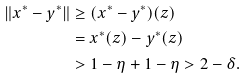Convert formula to latex. <formula><loc_0><loc_0><loc_500><loc_500>\| x ^ { * } - y ^ { * } \| & \geq ( x ^ { * } - y ^ { * } ) ( z ) \\ & = x ^ { * } ( z ) - y ^ { * } ( z ) \\ & > 1 - \eta + 1 - \eta > 2 - \delta .</formula> 